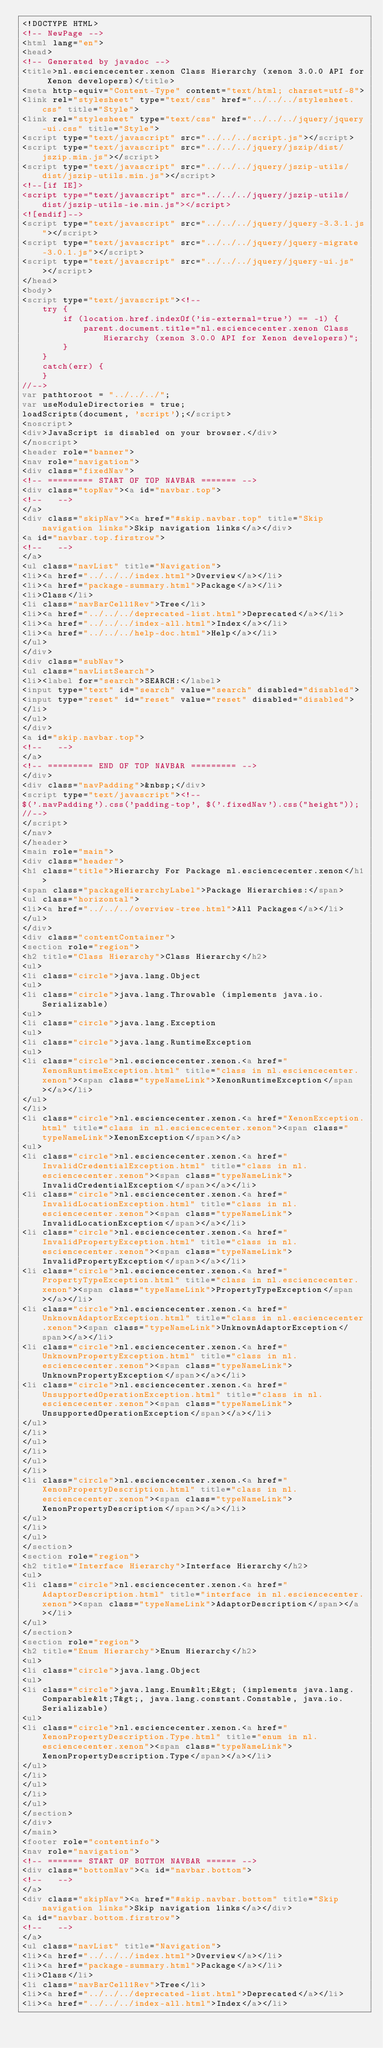Convert code to text. <code><loc_0><loc_0><loc_500><loc_500><_HTML_><!DOCTYPE HTML>
<!-- NewPage -->
<html lang="en">
<head>
<!-- Generated by javadoc -->
<title>nl.esciencecenter.xenon Class Hierarchy (xenon 3.0.0 API for Xenon developers)</title>
<meta http-equiv="Content-Type" content="text/html; charset=utf-8">
<link rel="stylesheet" type="text/css" href="../../../stylesheet.css" title="Style">
<link rel="stylesheet" type="text/css" href="../../../jquery/jquery-ui.css" title="Style">
<script type="text/javascript" src="../../../script.js"></script>
<script type="text/javascript" src="../../../jquery/jszip/dist/jszip.min.js"></script>
<script type="text/javascript" src="../../../jquery/jszip-utils/dist/jszip-utils.min.js"></script>
<!--[if IE]>
<script type="text/javascript" src="../../../jquery/jszip-utils/dist/jszip-utils-ie.min.js"></script>
<![endif]-->
<script type="text/javascript" src="../../../jquery/jquery-3.3.1.js"></script>
<script type="text/javascript" src="../../../jquery/jquery-migrate-3.0.1.js"></script>
<script type="text/javascript" src="../../../jquery/jquery-ui.js"></script>
</head>
<body>
<script type="text/javascript"><!--
    try {
        if (location.href.indexOf('is-external=true') == -1) {
            parent.document.title="nl.esciencecenter.xenon Class Hierarchy (xenon 3.0.0 API for Xenon developers)";
        }
    }
    catch(err) {
    }
//-->
var pathtoroot = "../../../";
var useModuleDirectories = true;
loadScripts(document, 'script');</script>
<noscript>
<div>JavaScript is disabled on your browser.</div>
</noscript>
<header role="banner">
<nav role="navigation">
<div class="fixedNav">
<!-- ========= START OF TOP NAVBAR ======= -->
<div class="topNav"><a id="navbar.top">
<!--   -->
</a>
<div class="skipNav"><a href="#skip.navbar.top" title="Skip navigation links">Skip navigation links</a></div>
<a id="navbar.top.firstrow">
<!--   -->
</a>
<ul class="navList" title="Navigation">
<li><a href="../../../index.html">Overview</a></li>
<li><a href="package-summary.html">Package</a></li>
<li>Class</li>
<li class="navBarCell1Rev">Tree</li>
<li><a href="../../../deprecated-list.html">Deprecated</a></li>
<li><a href="../../../index-all.html">Index</a></li>
<li><a href="../../../help-doc.html">Help</a></li>
</ul>
</div>
<div class="subNav">
<ul class="navListSearch">
<li><label for="search">SEARCH:</label>
<input type="text" id="search" value="search" disabled="disabled">
<input type="reset" id="reset" value="reset" disabled="disabled">
</li>
</ul>
</div>
<a id="skip.navbar.top">
<!--   -->
</a>
<!-- ========= END OF TOP NAVBAR ========= -->
</div>
<div class="navPadding">&nbsp;</div>
<script type="text/javascript"><!--
$('.navPadding').css('padding-top', $('.fixedNav').css("height"));
//-->
</script>
</nav>
</header>
<main role="main">
<div class="header">
<h1 class="title">Hierarchy For Package nl.esciencecenter.xenon</h1>
<span class="packageHierarchyLabel">Package Hierarchies:</span>
<ul class="horizontal">
<li><a href="../../../overview-tree.html">All Packages</a></li>
</ul>
</div>
<div class="contentContainer">
<section role="region">
<h2 title="Class Hierarchy">Class Hierarchy</h2>
<ul>
<li class="circle">java.lang.Object
<ul>
<li class="circle">java.lang.Throwable (implements java.io.Serializable)
<ul>
<li class="circle">java.lang.Exception
<ul>
<li class="circle">java.lang.RuntimeException
<ul>
<li class="circle">nl.esciencecenter.xenon.<a href="XenonRuntimeException.html" title="class in nl.esciencecenter.xenon"><span class="typeNameLink">XenonRuntimeException</span></a></li>
</ul>
</li>
<li class="circle">nl.esciencecenter.xenon.<a href="XenonException.html" title="class in nl.esciencecenter.xenon"><span class="typeNameLink">XenonException</span></a>
<ul>
<li class="circle">nl.esciencecenter.xenon.<a href="InvalidCredentialException.html" title="class in nl.esciencecenter.xenon"><span class="typeNameLink">InvalidCredentialException</span></a></li>
<li class="circle">nl.esciencecenter.xenon.<a href="InvalidLocationException.html" title="class in nl.esciencecenter.xenon"><span class="typeNameLink">InvalidLocationException</span></a></li>
<li class="circle">nl.esciencecenter.xenon.<a href="InvalidPropertyException.html" title="class in nl.esciencecenter.xenon"><span class="typeNameLink">InvalidPropertyException</span></a></li>
<li class="circle">nl.esciencecenter.xenon.<a href="PropertyTypeException.html" title="class in nl.esciencecenter.xenon"><span class="typeNameLink">PropertyTypeException</span></a></li>
<li class="circle">nl.esciencecenter.xenon.<a href="UnknownAdaptorException.html" title="class in nl.esciencecenter.xenon"><span class="typeNameLink">UnknownAdaptorException</span></a></li>
<li class="circle">nl.esciencecenter.xenon.<a href="UnknownPropertyException.html" title="class in nl.esciencecenter.xenon"><span class="typeNameLink">UnknownPropertyException</span></a></li>
<li class="circle">nl.esciencecenter.xenon.<a href="UnsupportedOperationException.html" title="class in nl.esciencecenter.xenon"><span class="typeNameLink">UnsupportedOperationException</span></a></li>
</ul>
</li>
</ul>
</li>
</ul>
</li>
<li class="circle">nl.esciencecenter.xenon.<a href="XenonPropertyDescription.html" title="class in nl.esciencecenter.xenon"><span class="typeNameLink">XenonPropertyDescription</span></a></li>
</ul>
</li>
</ul>
</section>
<section role="region">
<h2 title="Interface Hierarchy">Interface Hierarchy</h2>
<ul>
<li class="circle">nl.esciencecenter.xenon.<a href="AdaptorDescription.html" title="interface in nl.esciencecenter.xenon"><span class="typeNameLink">AdaptorDescription</span></a></li>
</ul>
</section>
<section role="region">
<h2 title="Enum Hierarchy">Enum Hierarchy</h2>
<ul>
<li class="circle">java.lang.Object
<ul>
<li class="circle">java.lang.Enum&lt;E&gt; (implements java.lang.Comparable&lt;T&gt;, java.lang.constant.Constable, java.io.Serializable)
<ul>
<li class="circle">nl.esciencecenter.xenon.<a href="XenonPropertyDescription.Type.html" title="enum in nl.esciencecenter.xenon"><span class="typeNameLink">XenonPropertyDescription.Type</span></a></li>
</ul>
</li>
</ul>
</li>
</ul>
</section>
</div>
</main>
<footer role="contentinfo">
<nav role="navigation">
<!-- ======= START OF BOTTOM NAVBAR ====== -->
<div class="bottomNav"><a id="navbar.bottom">
<!--   -->
</a>
<div class="skipNav"><a href="#skip.navbar.bottom" title="Skip navigation links">Skip navigation links</a></div>
<a id="navbar.bottom.firstrow">
<!--   -->
</a>
<ul class="navList" title="Navigation">
<li><a href="../../../index.html">Overview</a></li>
<li><a href="package-summary.html">Package</a></li>
<li>Class</li>
<li class="navBarCell1Rev">Tree</li>
<li><a href="../../../deprecated-list.html">Deprecated</a></li>
<li><a href="../../../index-all.html">Index</a></li></code> 